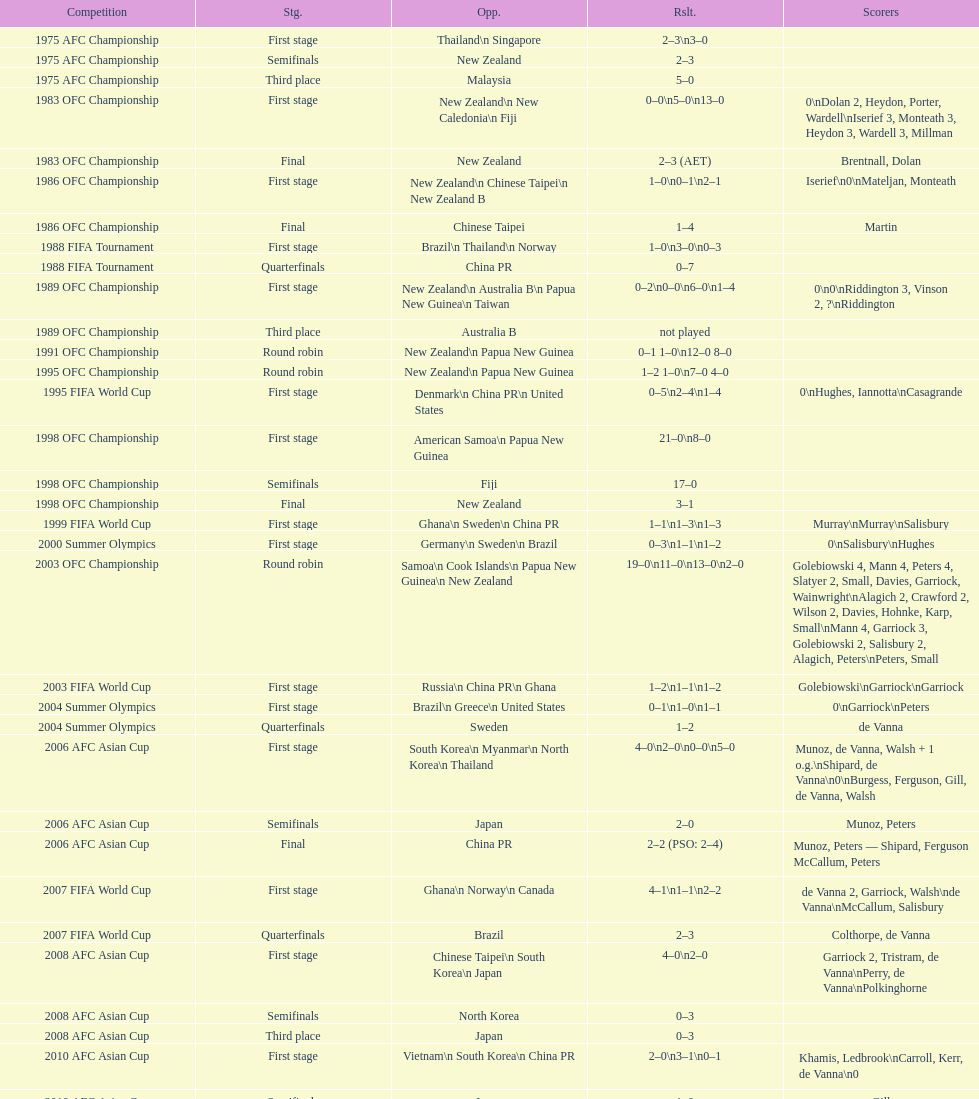What it the total number of countries in the first stage of the 2008 afc asian cup? 4. Can you parse all the data within this table? {'header': ['Competition', 'Stg.', 'Opp.', 'Rslt.', 'Scorers'], 'rows': [['1975 AFC Championship', 'First stage', 'Thailand\\n\xa0Singapore', '2–3\\n3–0', ''], ['1975 AFC Championship', 'Semifinals', 'New Zealand', '2–3', ''], ['1975 AFC Championship', 'Third place', 'Malaysia', '5–0', ''], ['1983 OFC Championship', 'First stage', 'New Zealand\\n\xa0New Caledonia\\n\xa0Fiji', '0–0\\n5–0\\n13–0', '0\\nDolan 2, Heydon, Porter, Wardell\\nIserief 3, Monteath 3, Heydon 3, Wardell 3, Millman'], ['1983 OFC Championship', 'Final', 'New Zealand', '2–3 (AET)', 'Brentnall, Dolan'], ['1986 OFC Championship', 'First stage', 'New Zealand\\n\xa0Chinese Taipei\\n New Zealand B', '1–0\\n0–1\\n2–1', 'Iserief\\n0\\nMateljan, Monteath'], ['1986 OFC Championship', 'Final', 'Chinese Taipei', '1–4', 'Martin'], ['1988 FIFA Tournament', 'First stage', 'Brazil\\n\xa0Thailand\\n\xa0Norway', '1–0\\n3–0\\n0–3', ''], ['1988 FIFA Tournament', 'Quarterfinals', 'China PR', '0–7', ''], ['1989 OFC Championship', 'First stage', 'New Zealand\\n Australia B\\n\xa0Papua New Guinea\\n\xa0Taiwan', '0–2\\n0–0\\n6–0\\n1–4', '0\\n0\\nRiddington 3, Vinson 2,\xa0?\\nRiddington'], ['1989 OFC Championship', 'Third place', 'Australia B', 'not played', ''], ['1991 OFC Championship', 'Round robin', 'New Zealand\\n\xa0Papua New Guinea', '0–1 1–0\\n12–0 8–0', ''], ['1995 OFC Championship', 'Round robin', 'New Zealand\\n\xa0Papua New Guinea', '1–2 1–0\\n7–0 4–0', ''], ['1995 FIFA World Cup', 'First stage', 'Denmark\\n\xa0China PR\\n\xa0United States', '0–5\\n2–4\\n1–4', '0\\nHughes, Iannotta\\nCasagrande'], ['1998 OFC Championship', 'First stage', 'American Samoa\\n\xa0Papua New Guinea', '21–0\\n8–0', ''], ['1998 OFC Championship', 'Semifinals', 'Fiji', '17–0', ''], ['1998 OFC Championship', 'Final', 'New Zealand', '3–1', ''], ['1999 FIFA World Cup', 'First stage', 'Ghana\\n\xa0Sweden\\n\xa0China PR', '1–1\\n1–3\\n1–3', 'Murray\\nMurray\\nSalisbury'], ['2000 Summer Olympics', 'First stage', 'Germany\\n\xa0Sweden\\n\xa0Brazil', '0–3\\n1–1\\n1–2', '0\\nSalisbury\\nHughes'], ['2003 OFC Championship', 'Round robin', 'Samoa\\n\xa0Cook Islands\\n\xa0Papua New Guinea\\n\xa0New Zealand', '19–0\\n11–0\\n13–0\\n2–0', 'Golebiowski 4, Mann 4, Peters 4, Slatyer 2, Small, Davies, Garriock, Wainwright\\nAlagich 2, Crawford 2, Wilson 2, Davies, Hohnke, Karp, Small\\nMann 4, Garriock 3, Golebiowski 2, Salisbury 2, Alagich, Peters\\nPeters, Small'], ['2003 FIFA World Cup', 'First stage', 'Russia\\n\xa0China PR\\n\xa0Ghana', '1–2\\n1–1\\n1–2', 'Golebiowski\\nGarriock\\nGarriock'], ['2004 Summer Olympics', 'First stage', 'Brazil\\n\xa0Greece\\n\xa0United States', '0–1\\n1–0\\n1–1', '0\\nGarriock\\nPeters'], ['2004 Summer Olympics', 'Quarterfinals', 'Sweden', '1–2', 'de Vanna'], ['2006 AFC Asian Cup', 'First stage', 'South Korea\\n\xa0Myanmar\\n\xa0North Korea\\n\xa0Thailand', '4–0\\n2–0\\n0–0\\n5–0', 'Munoz, de Vanna, Walsh + 1 o.g.\\nShipard, de Vanna\\n0\\nBurgess, Ferguson, Gill, de Vanna, Walsh'], ['2006 AFC Asian Cup', 'Semifinals', 'Japan', '2–0', 'Munoz, Peters'], ['2006 AFC Asian Cup', 'Final', 'China PR', '2–2 (PSO: 2–4)', 'Munoz, Peters — Shipard, Ferguson McCallum, Peters'], ['2007 FIFA World Cup', 'First stage', 'Ghana\\n\xa0Norway\\n\xa0Canada', '4–1\\n1–1\\n2–2', 'de Vanna 2, Garriock, Walsh\\nde Vanna\\nMcCallum, Salisbury'], ['2007 FIFA World Cup', 'Quarterfinals', 'Brazil', '2–3', 'Colthorpe, de Vanna'], ['2008 AFC Asian Cup', 'First stage', 'Chinese Taipei\\n\xa0South Korea\\n\xa0Japan', '4–0\\n2–0', 'Garriock 2, Tristram, de Vanna\\nPerry, de Vanna\\nPolkinghorne'], ['2008 AFC Asian Cup', 'Semifinals', 'North Korea', '0–3', ''], ['2008 AFC Asian Cup', 'Third place', 'Japan', '0–3', ''], ['2010 AFC Asian Cup', 'First stage', 'Vietnam\\n\xa0South Korea\\n\xa0China PR', '2–0\\n3–1\\n0–1', 'Khamis, Ledbrook\\nCarroll, Kerr, de Vanna\\n0'], ['2010 AFC Asian Cup', 'Semifinals', 'Japan', '1–0', 'Gill'], ['2010 AFC Asian Cup', 'Final', 'North Korea', '1–1 (PSO: 5–4)', 'Kerr — PSO: Shipard, Ledbrook, Gill, Garriock, Simon'], ['2011 FIFA World Cup', 'First stage', 'Brazil\\n\xa0Equatorial Guinea\\n\xa0Norway', '0–1\\n3–2\\n2–1', '0\\nvan Egmond, Khamis, de Vanna\\nSimon 2'], ['2011 FIFA World Cup', 'Quarterfinals', 'Sweden', '1–3', 'Perry'], ['2012 Summer Olympics\\nAFC qualification', 'Final round', 'North Korea\\n\xa0Thailand\\n\xa0Japan\\n\xa0China PR\\n\xa0South Korea', '0–1\\n5–1\\n0–1\\n1–0\\n2–1', '0\\nHeyman 2, Butt, van Egmond, Simon\\n0\\nvan Egmond\\nButt, de Vanna'], ['2014 AFC Asian Cup', 'First stage', 'Japan\\n\xa0Jordan\\n\xa0Vietnam', 'TBD\\nTBD\\nTBD', '']]} 